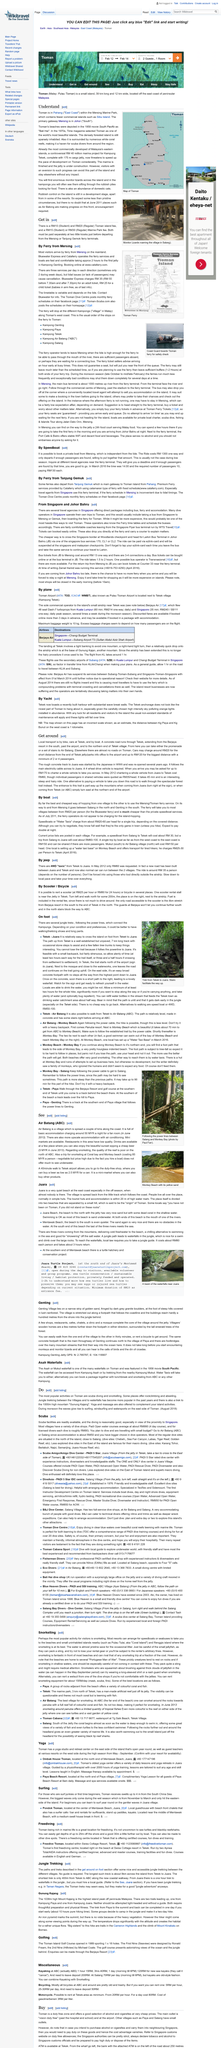Specify some key components in this picture. Mount Kajang has a height of 1038 meters. The shortest trek is only 400 meters long. The cost of a speedboat ride from Salang to Tekek is approximately RM 30, with the crossing being approximately RM 30. Tioman is located in Pahang and is situated within the Mersing Marine Park. The Tioman Island Golf Course was designed by Ronald Fream, who was responsible for creating the first nine holes of the course. 